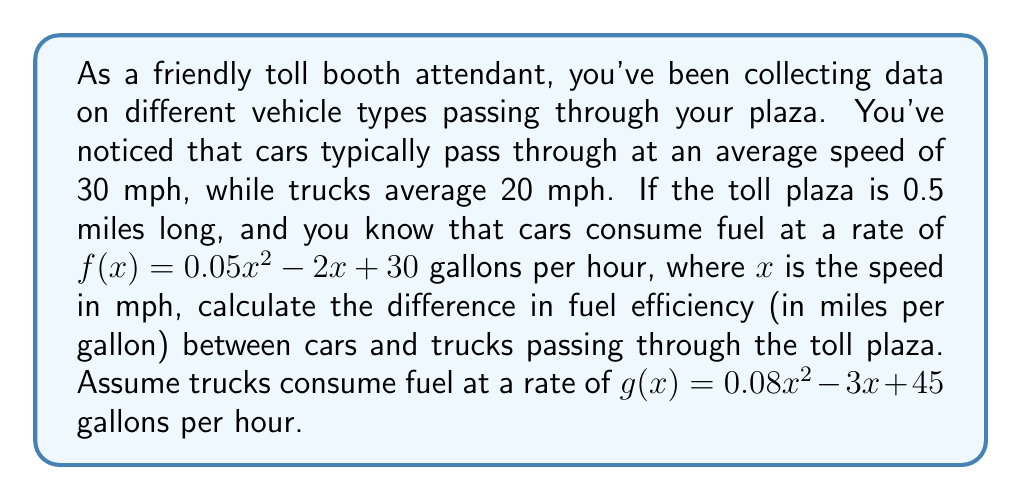Give your solution to this math problem. To solve this problem, we'll follow these steps:

1) Calculate the time taken by cars and trucks to pass through the toll plaza:
   - Distance = 0.5 miles
   - Time = Distance / Speed
   - For cars: $T_c = 0.5 / 30 = 1/60$ hour
   - For trucks: $T_t = 0.5 / 20 = 1/40$ hour

2) Calculate fuel consumption for cars:
   $f(30) = 0.05(30)^2 - 2(30) + 30 = 45 - 60 + 30 = 15$ gallons per hour
   Fuel used by car = $15 * (1/60) = 0.25$ gallons

3) Calculate fuel consumption for trucks:
   $g(20) = 0.08(20)^2 - 3(20) + 45 = 32 - 60 + 45 = 17$ gallons per hour
   Fuel used by truck = $17 * (1/40) = 0.425$ gallons

4) Calculate fuel efficiency:
   Efficiency = Distance / Fuel Used
   - For cars: $E_c = 0.5 / 0.25 = 2$ miles per gallon
   - For trucks: $E_t = 0.5 / 0.425 \approx 1.176$ miles per gallon

5) Calculate the difference in fuel efficiency:
   Difference = $E_c - E_t = 2 - 1.176 = 0.824$ miles per gallon
Answer: The difference in fuel efficiency between cars and trucks passing through the toll plaza is approximately 0.824 miles per gallon, with cars being more fuel-efficient. 